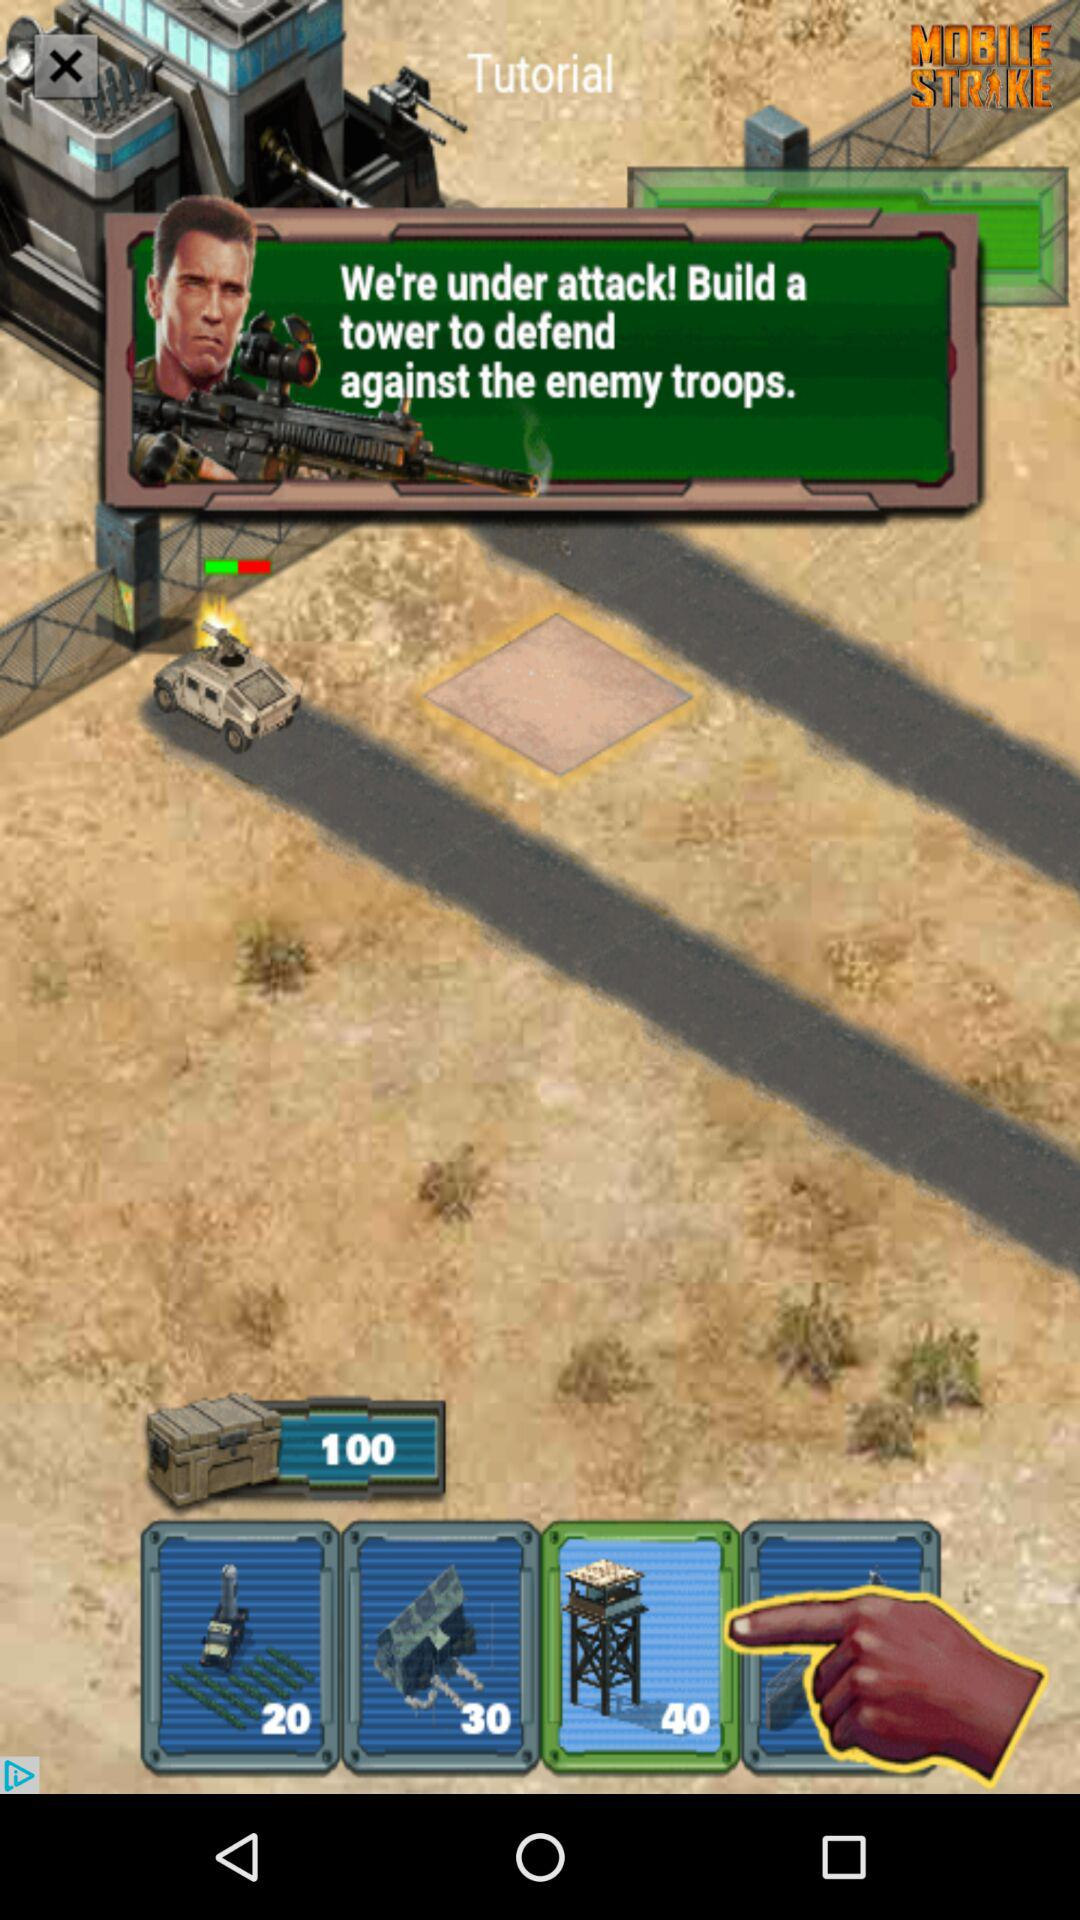What is the name of the game application? The name of the game application is "MOBILE STRIKE". 